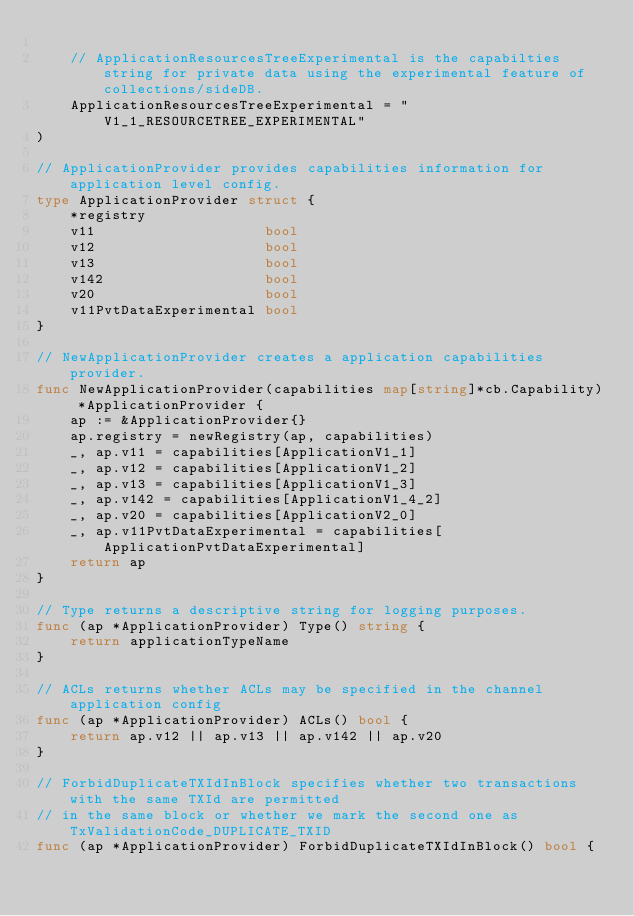<code> <loc_0><loc_0><loc_500><loc_500><_Go_>
	// ApplicationResourcesTreeExperimental is the capabilties string for private data using the experimental feature of collections/sideDB.
	ApplicationResourcesTreeExperimental = "V1_1_RESOURCETREE_EXPERIMENTAL"
)

// ApplicationProvider provides capabilities information for application level config.
type ApplicationProvider struct {
	*registry
	v11                    bool
	v12                    bool
	v13                    bool
	v142                   bool
	v20                    bool
	v11PvtDataExperimental bool
}

// NewApplicationProvider creates a application capabilities provider.
func NewApplicationProvider(capabilities map[string]*cb.Capability) *ApplicationProvider {
	ap := &ApplicationProvider{}
	ap.registry = newRegistry(ap, capabilities)
	_, ap.v11 = capabilities[ApplicationV1_1]
	_, ap.v12 = capabilities[ApplicationV1_2]
	_, ap.v13 = capabilities[ApplicationV1_3]
	_, ap.v142 = capabilities[ApplicationV1_4_2]
	_, ap.v20 = capabilities[ApplicationV2_0]
	_, ap.v11PvtDataExperimental = capabilities[ApplicationPvtDataExperimental]
	return ap
}

// Type returns a descriptive string for logging purposes.
func (ap *ApplicationProvider) Type() string {
	return applicationTypeName
}

// ACLs returns whether ACLs may be specified in the channel application config
func (ap *ApplicationProvider) ACLs() bool {
	return ap.v12 || ap.v13 || ap.v142 || ap.v20
}

// ForbidDuplicateTXIdInBlock specifies whether two transactions with the same TXId are permitted
// in the same block or whether we mark the second one as TxValidationCode_DUPLICATE_TXID
func (ap *ApplicationProvider) ForbidDuplicateTXIdInBlock() bool {</code> 